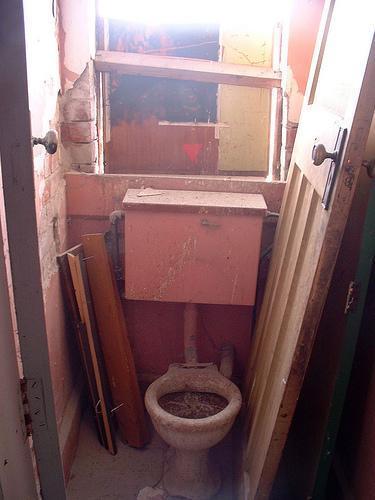How many toilets are there?
Give a very brief answer. 1. 